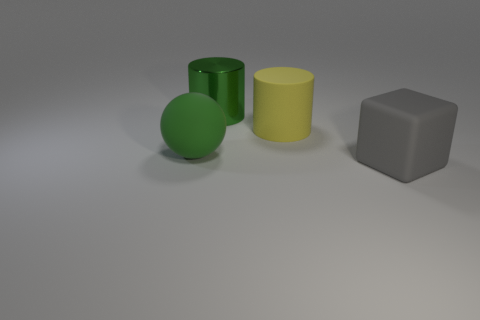Add 4 big green cubes. How many objects exist? 8 Subtract all spheres. How many objects are left? 3 Add 4 large blue rubber cylinders. How many large blue rubber cylinders exist? 4 Subtract 0 red cubes. How many objects are left? 4 Subtract all matte cylinders. Subtract all big yellow objects. How many objects are left? 2 Add 2 big green balls. How many big green balls are left? 3 